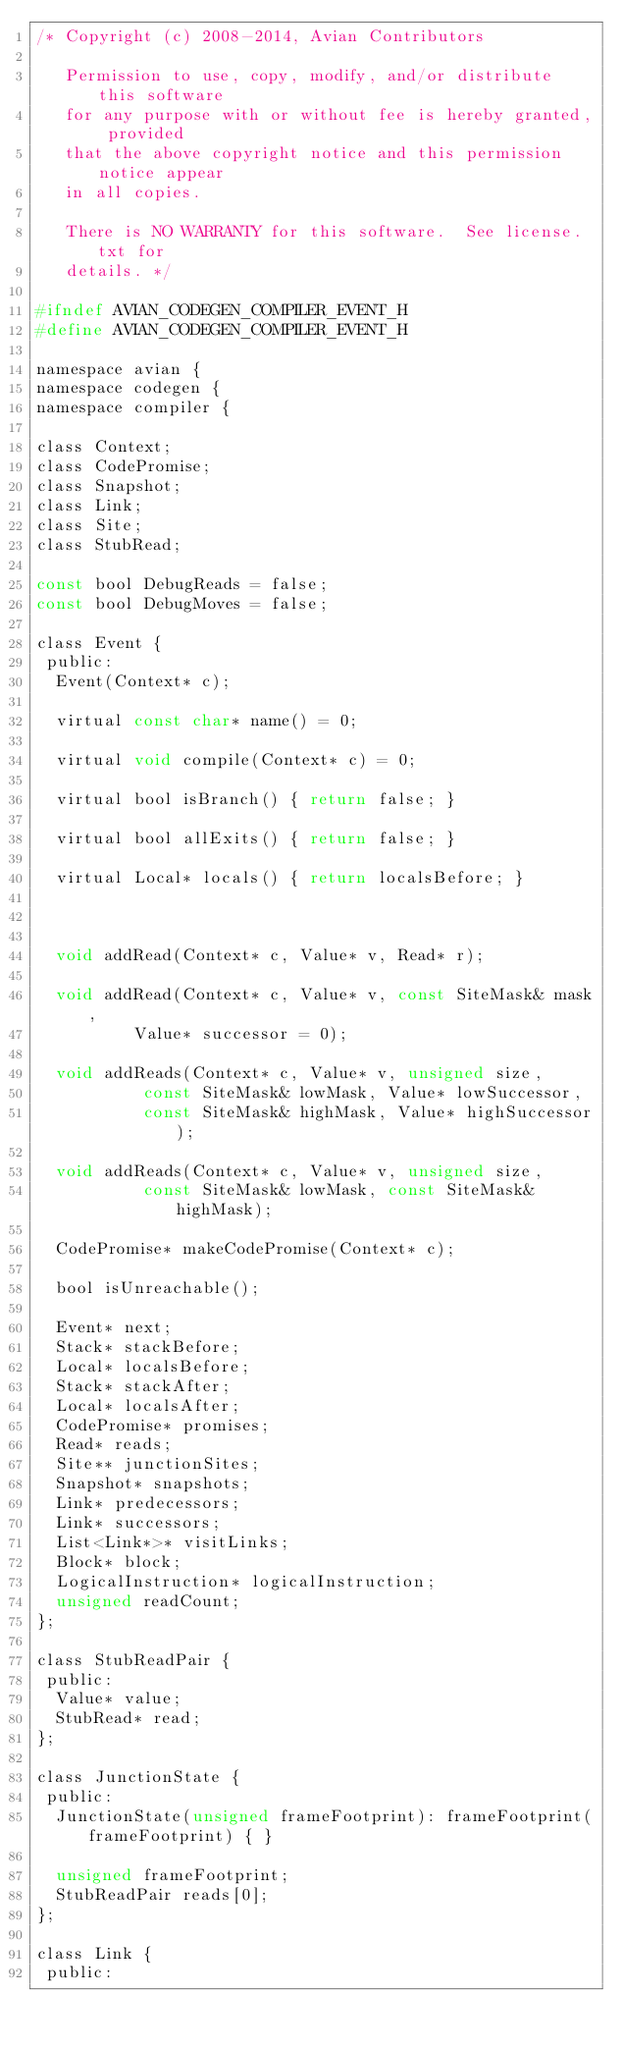Convert code to text. <code><loc_0><loc_0><loc_500><loc_500><_C_>/* Copyright (c) 2008-2014, Avian Contributors

   Permission to use, copy, modify, and/or distribute this software
   for any purpose with or without fee is hereby granted, provided
   that the above copyright notice and this permission notice appear
   in all copies.

   There is NO WARRANTY for this software.  See license.txt for
   details. */

#ifndef AVIAN_CODEGEN_COMPILER_EVENT_H
#define AVIAN_CODEGEN_COMPILER_EVENT_H

namespace avian {
namespace codegen {
namespace compiler {

class Context;
class CodePromise;
class Snapshot;
class Link;
class Site;
class StubRead;

const bool DebugReads = false;
const bool DebugMoves = false;

class Event {
 public:
  Event(Context* c);

  virtual const char* name() = 0;

  virtual void compile(Context* c) = 0;

  virtual bool isBranch() { return false; }

  virtual bool allExits() { return false; }

  virtual Local* locals() { return localsBefore; }



  void addRead(Context* c, Value* v, Read* r);

  void addRead(Context* c, Value* v, const SiteMask& mask,
          Value* successor = 0);

  void addReads(Context* c, Value* v, unsigned size,
           const SiteMask& lowMask, Value* lowSuccessor,
           const SiteMask& highMask, Value* highSuccessor);

  void addReads(Context* c, Value* v, unsigned size,
           const SiteMask& lowMask, const SiteMask& highMask);

  CodePromise* makeCodePromise(Context* c);

  bool isUnreachable();

  Event* next;
  Stack* stackBefore;
  Local* localsBefore;
  Stack* stackAfter;
  Local* localsAfter;
  CodePromise* promises;
  Read* reads;
  Site** junctionSites;
  Snapshot* snapshots;
  Link* predecessors;
  Link* successors;
  List<Link*>* visitLinks;
  Block* block;
  LogicalInstruction* logicalInstruction;
  unsigned readCount;
};

class StubReadPair {
 public:
  Value* value;
  StubRead* read;
};

class JunctionState {
 public:
  JunctionState(unsigned frameFootprint): frameFootprint(frameFootprint) { }

  unsigned frameFootprint;
  StubReadPair reads[0];
};

class Link {
 public:</code> 